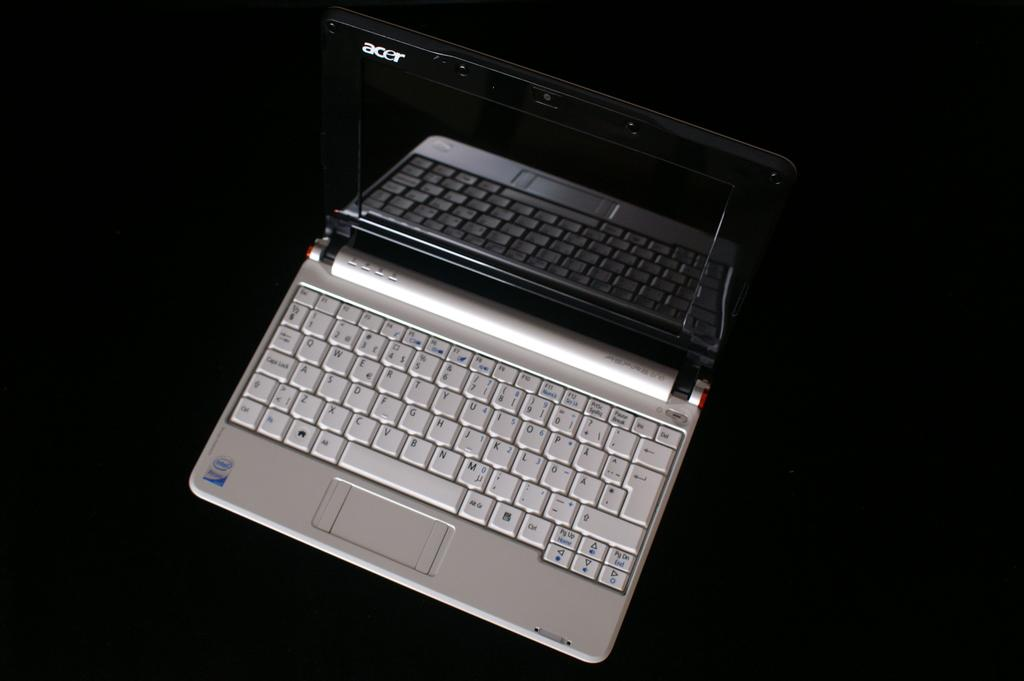<image>
Present a compact description of the photo's key features. A black and silver laptop with acer written in the upper left hand corner. 